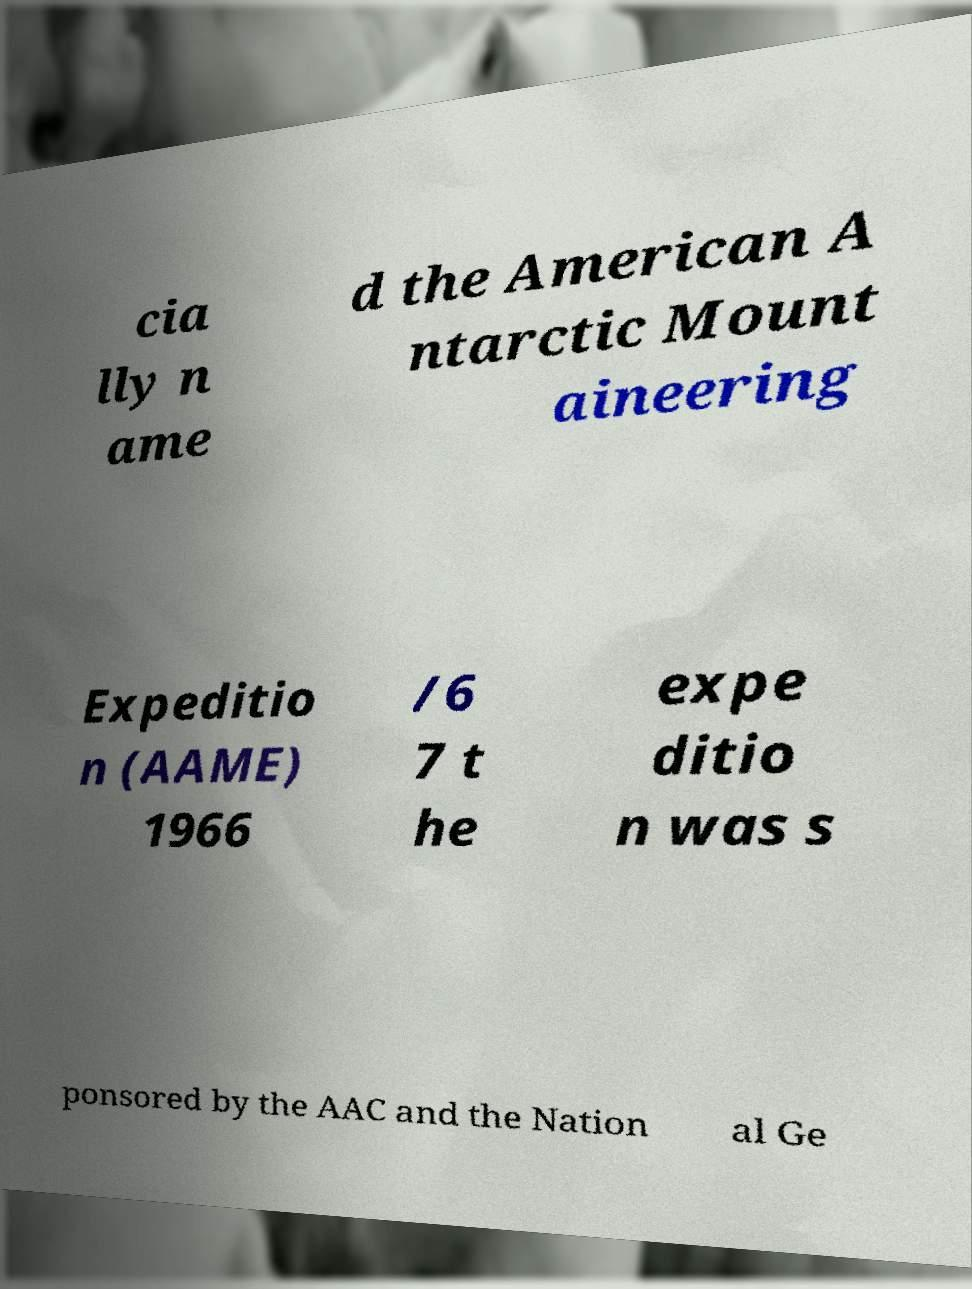There's text embedded in this image that I need extracted. Can you transcribe it verbatim? cia lly n ame d the American A ntarctic Mount aineering Expeditio n (AAME) 1966 /6 7 t he expe ditio n was s ponsored by the AAC and the Nation al Ge 